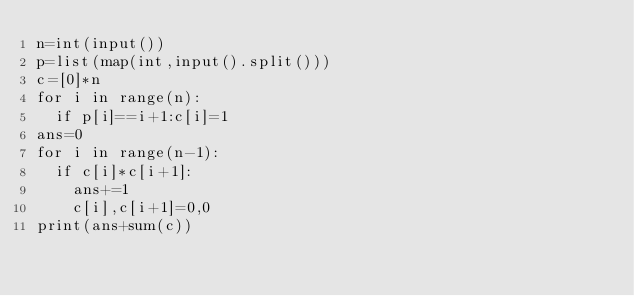Convert code to text. <code><loc_0><loc_0><loc_500><loc_500><_Python_>n=int(input())
p=list(map(int,input().split()))
c=[0]*n
for i in range(n):
  if p[i]==i+1:c[i]=1
ans=0
for i in range(n-1):
  if c[i]*c[i+1]:
    ans+=1
    c[i],c[i+1]=0,0
print(ans+sum(c))</code> 